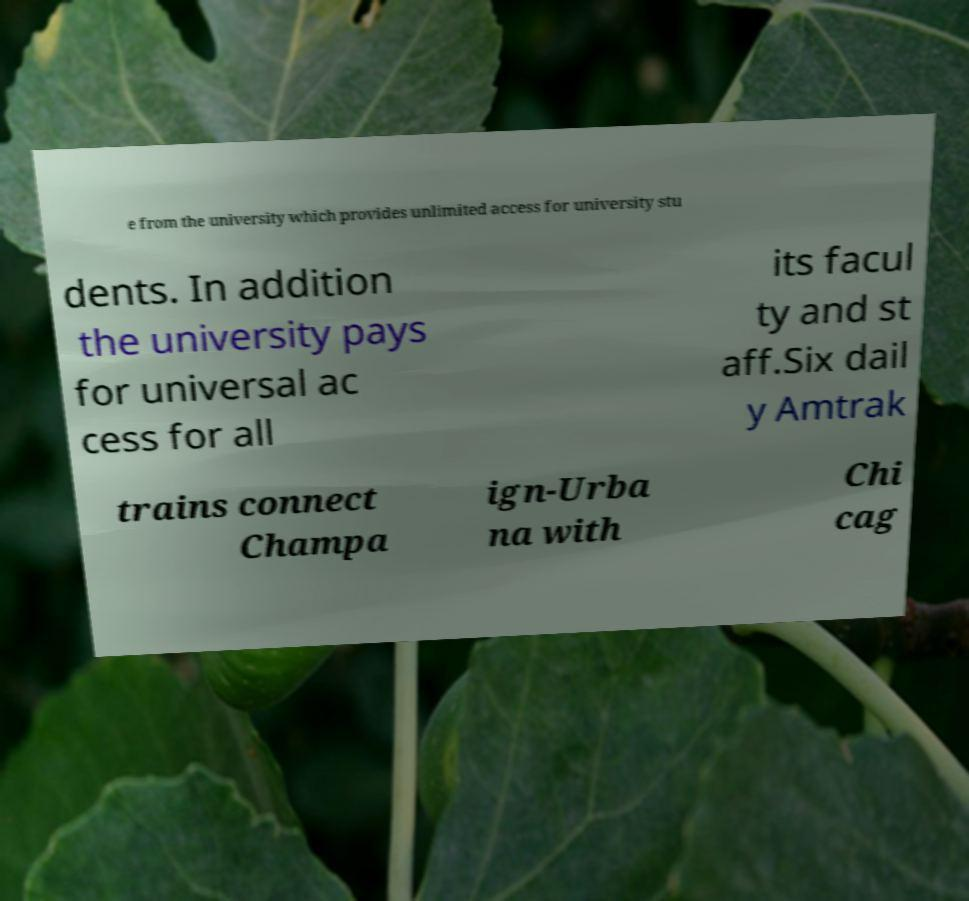Could you extract and type out the text from this image? e from the university which provides unlimited access for university stu dents. In addition the university pays for universal ac cess for all its facul ty and st aff.Six dail y Amtrak trains connect Champa ign-Urba na with Chi cag 